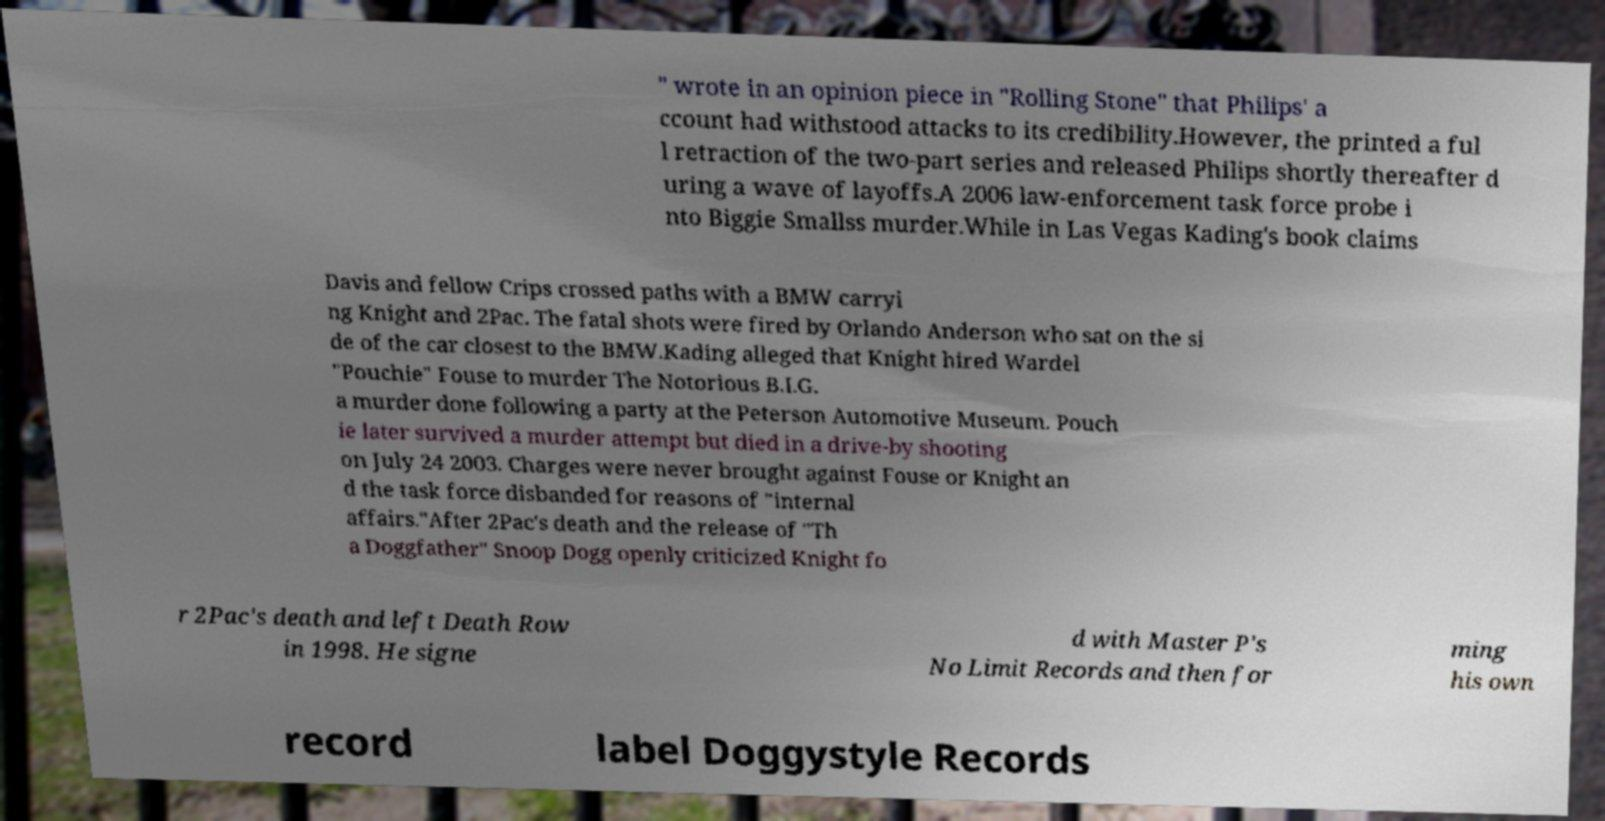Please identify and transcribe the text found in this image. " wrote in an opinion piece in "Rolling Stone" that Philips' a ccount had withstood attacks to its credibility.However, the printed a ful l retraction of the two-part series and released Philips shortly thereafter d uring a wave of layoffs.A 2006 law-enforcement task force probe i nto Biggie Smallss murder.While in Las Vegas Kading's book claims Davis and fellow Crips crossed paths with a BMW carryi ng Knight and 2Pac. The fatal shots were fired by Orlando Anderson who sat on the si de of the car closest to the BMW.Kading alleged that Knight hired Wardel "Pouchie" Fouse to murder The Notorious B.I.G. a murder done following a party at the Peterson Automotive Museum. Pouch ie later survived a murder attempt but died in a drive-by shooting on July 24 2003. Charges were never brought against Fouse or Knight an d the task force disbanded for reasons of "internal affairs."After 2Pac's death and the release of "Th a Doggfather" Snoop Dogg openly criticized Knight fo r 2Pac's death and left Death Row in 1998. He signe d with Master P's No Limit Records and then for ming his own record label Doggystyle Records 